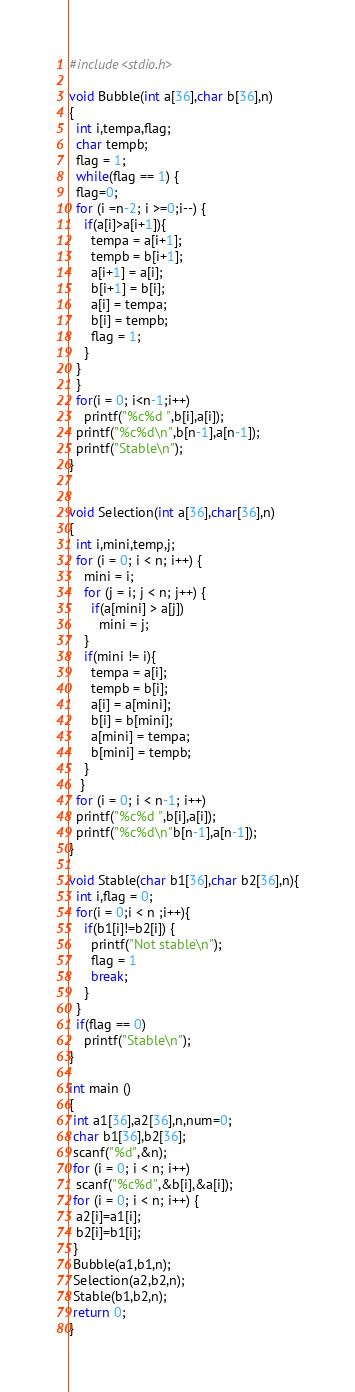<code> <loc_0><loc_0><loc_500><loc_500><_C_>#include<stdio.h>
 
void Bubble(int a[36],char b[36],n)
{
  int i,tempa,flag;
  char tempb;
  flag = 1;
  while(flag == 1) {
  flag=0;
  for (i =n-2; i >=0;i--) {
    if(a[i]>a[i+1]){
      tempa = a[i+1];
      tempb = b[i+1];
      a[i+1] = a[i];
      b[i+1] = b[i];
      a[i] = tempa;
      b[i] = tempb;
      flag = 1;
    }
  }
  }
  for(i = 0; i<n-1;i++)
    printf("%c%d ",b[i],a[i]);
  printf("%c%d\n",b[n-1],a[n-1]);
  printf("Stable\n");
}
 

void Selection(int a[36],char[36],n)
{
  int i,mini,temp,j;
  for (i = 0; i < n; i++) {
    mini = i;
    for (j = i; j < n; j++) {
      if(a[mini] > a[j])
        mini = j;
    }
    if(mini != i){
      tempa = a[i];
      tempb = b[i];
      a[i] = a[mini];
      b[i] = b[mini];
      a[mini] = tempa;
      b[mini] = tempb;
    }  
   }
  for (i = 0; i < n-1; i++)
  printf("%c%d ",b[i],a[i]);
  printf("%c%d\n"b[n-1],a[n-1]);
}

void Stable(char b1[36],char b2[36],n){
  int i,flag = 0;
  for(i = 0;i < n ;i++){
    if(b1[i]!=b2[i]) {
      printf("Not stable\n");
      flag = 1
      break;
    }
  }
  if(flag == 0)
    printf("Stable\n");  
}

int main ()
{
 int a1[36],a2[36],n,num=0;
 char b1[36],b2[36];
 scanf("%d",&n);
 for (i = 0; i < n; i++) 
  scanf("%c%d",&b[i],&a[i]);
 for (i = 0; i < n; i++) {
  a2[i]=a1[i];
  b2[i]=b1[i];
 }
 Bubble(a1,b1,n);
 Selection(a2,b2,n);
 Stable(b1,b2,n);
 return 0;
}</code> 